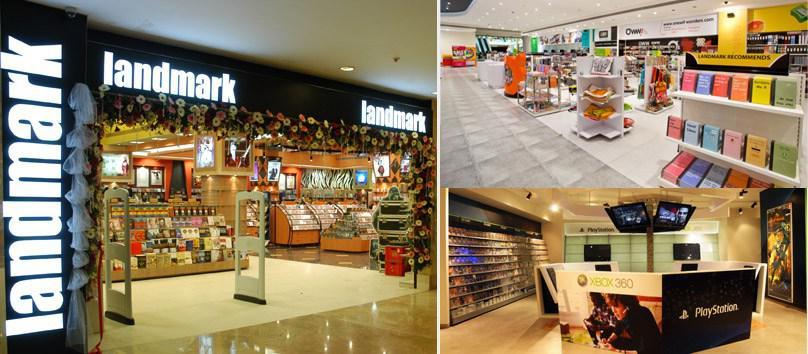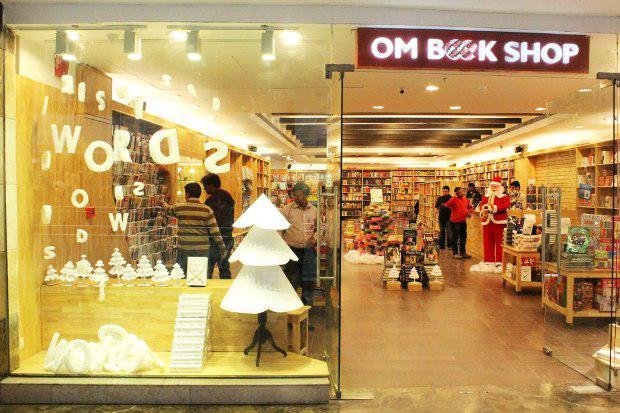The first image is the image on the left, the second image is the image on the right. Assess this claim about the two images: "One bookshop interior features a dimensional tiered display of books in front of aisles of book shelves and an exposed beam ceiling with dome-shaped lights.". Correct or not? Answer yes or no. No. The first image is the image on the left, the second image is the image on the right. Considering the images on both sides, is "The name of the store is visible in exactly one of the images." valid? Answer yes or no. No. 